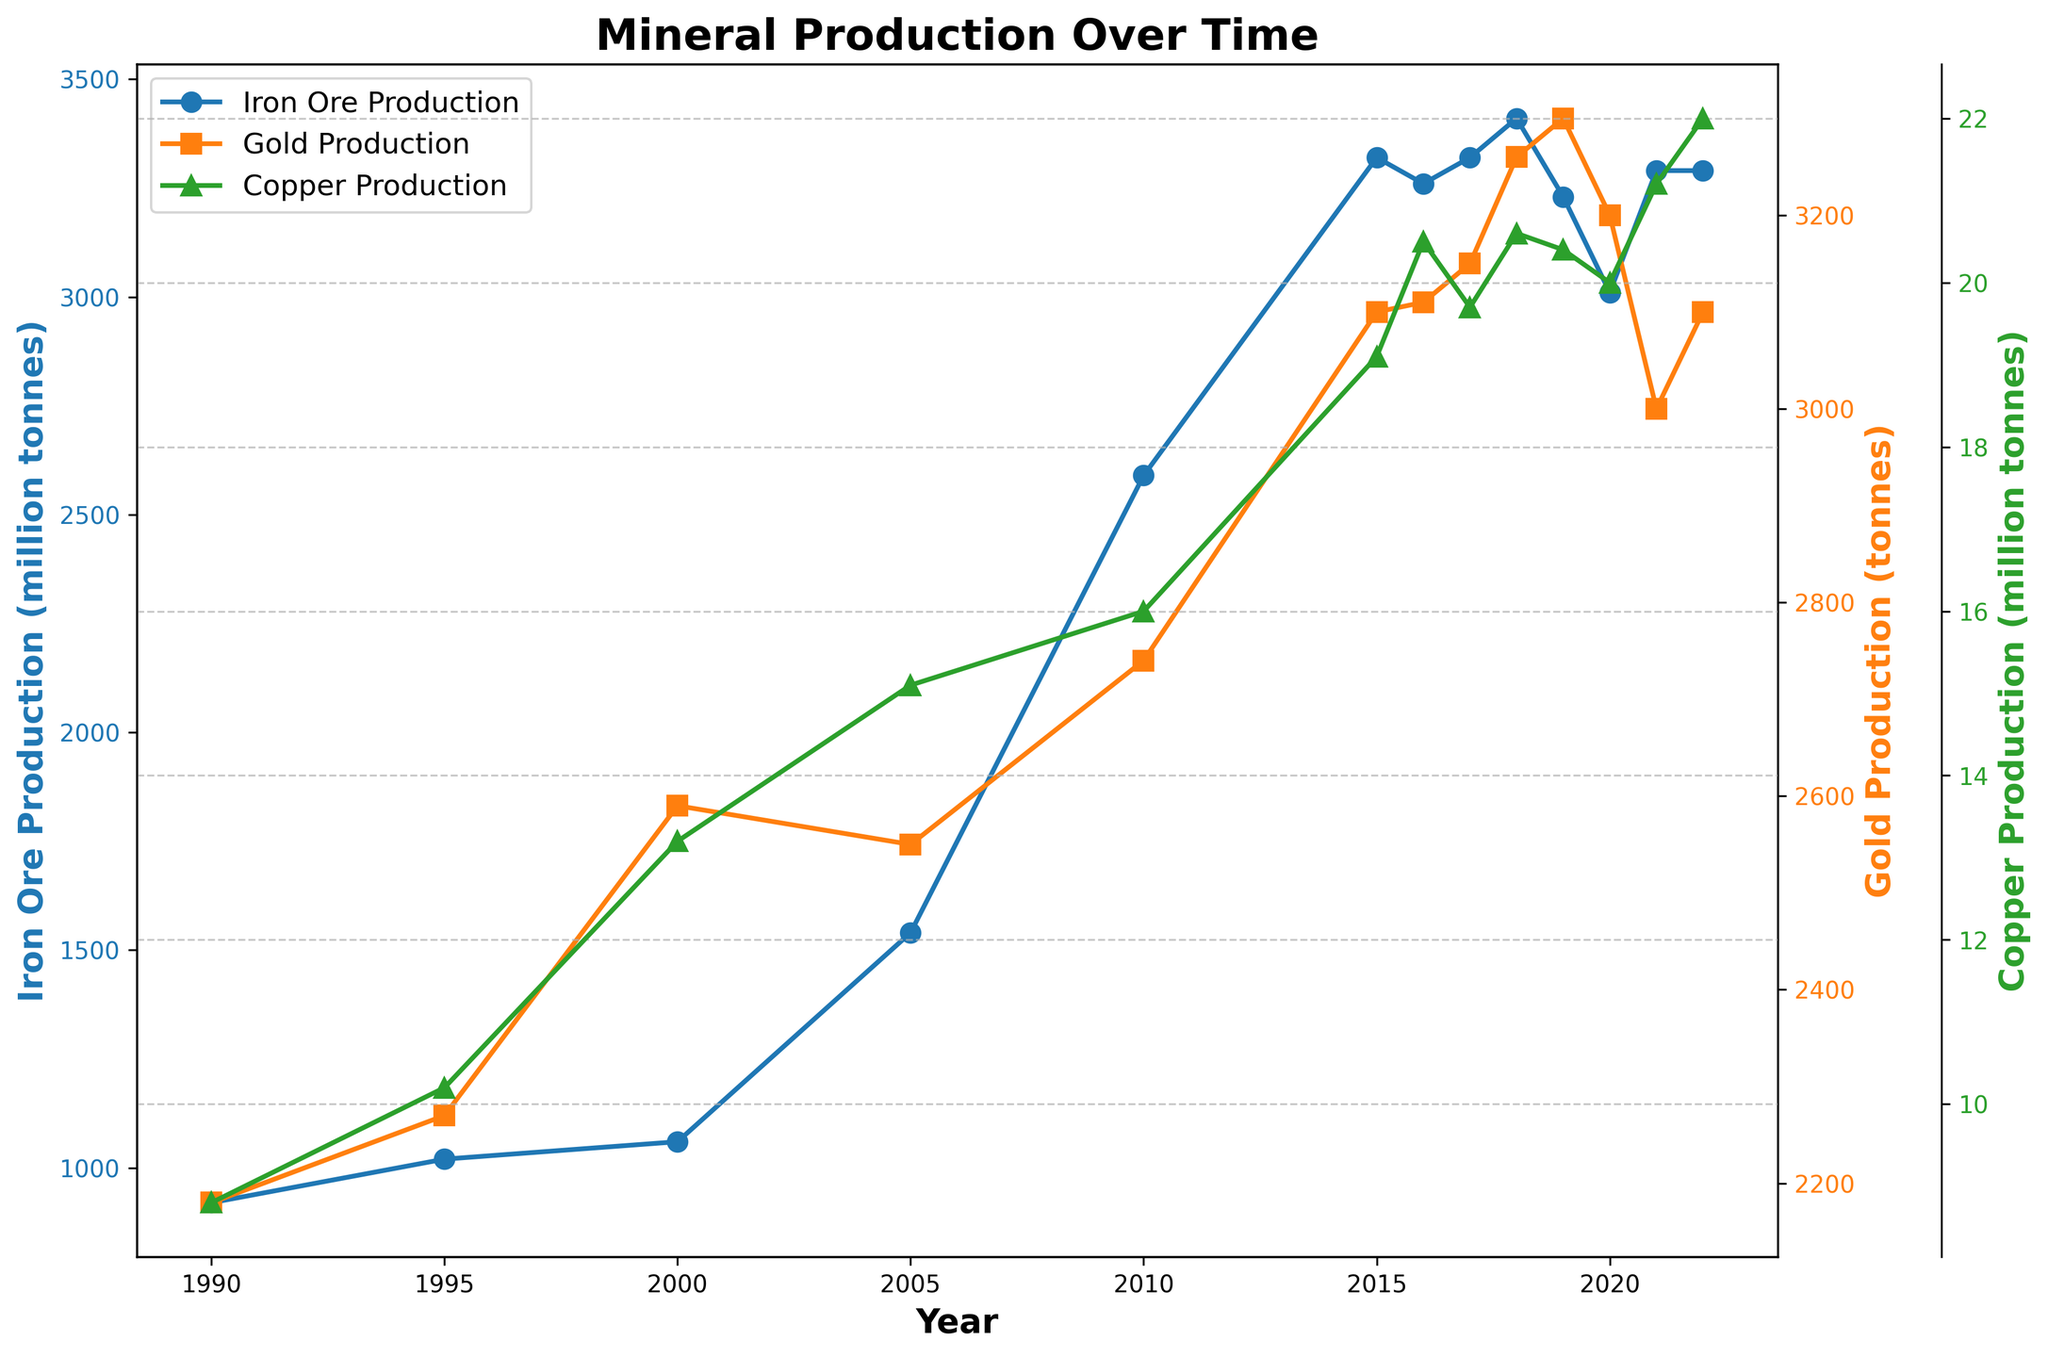What was the approximate production of Iron Ore in 2005 and 2010? To find the production of Iron Ore in both years, you can look at the Iron Ore line (marked with circles) on the chart and note the values at the points corresponding to the years 2005 and 2010. Iron Ore production was around 1540 million tonnes in 2005 and 2590 million tonnes in 2010.
Answer: 1540 million tonnes in 2005; 2590 million tonnes in 2010 How did Gold production change from 2000 to 2005? To assess the change in Gold production between 2000 and 2005, examine the Gold line (marked with squares). Production increased from approximately 2590 tonnes in 2000 to 2550 tonnes in 2005. Although there's a slight decrease, the change is small.
Answer: Decreased slightly Which commodity experienced the sharpest rise in production value between 2010 and 2015? To find which commodity had the sharpest increase in production value, compare the slopes of the value lines of Iron Ore, Gold, and Copper between 2010 and 2015. Observe that the Iron Ore's value line (blue) shows a sharp increase during this period.
Answer: Iron Ore What is the trend in Copper production from 1990 to 2022? To identify the trend in Copper production, follow the Copper line (marked with triangles) from 1990 to 2022. It shows a general upward trend with some fluctuations, increasing overall from 8.8 million tonnes in 1990 to 22.0 million tonnes in 2022.
Answer: Increasing trend Which year saw the highest production of Gold? To determine the year with the highest Gold production, look at the peak of the gold line (marked with squares). The highest production visually appears around 2018, which corresponds to 3260 tonnes.
Answer: 2018 What can be said about the changes in Iron Ore production and its value between 2010 and 2021? Examine the Iron Ore production and value lines for the given period. The production remained high and relatively stable from 2010 to 2021, while the value saw significant fluctuations, with the peak value around 2021.
Answer: High and stable production, fluctuating value Compare the relative stability of production for Iron Ore and Copper since 2000. Look at the production lines for Iron Ore and Copper from 2000 onwards. Iron Ore production shows more significant fluctuations, whereas Copper production demonstrates more stable, consistent growth.
Answer: Copper is more stable What is the visual difference between the Iron Ore and Gold production lines? Compare the visual appearance of both lines. The Iron Ore line (circles) shows larger fluctuations and more significant increases over time, whereas the Gold line (squares) appears smoother with smaller changes.
Answer: Iron Ore is more fluctuating How did the value of Gold change in the year 2020 compared to 2019? Check the Gold value line around the years 2019 and 2020. It shows an increase from approximately 142.9 billion USD in 2019 to 180.5 billion USD in 2020.
Answer: Increased 